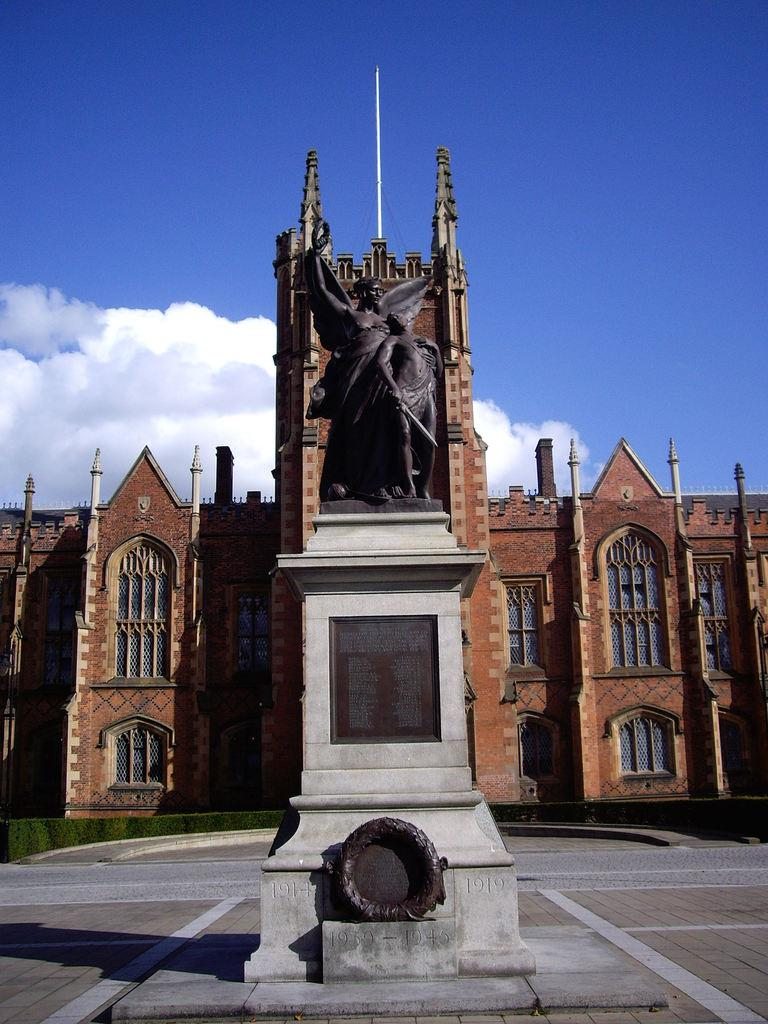What type of objects are depicted in the image? There are sculptures of persons in the image. Where are the sculptures located? The sculptures are on a block. What else can be seen in the image besides the sculptures? There is a building in the image. What is visible in the sky in the image? There are clouds in the sky. What type of cloth is draped over the sculptures in the image? There is no cloth draped over the sculptures in the image; they are depicted as standing on the block without any additional coverings. 